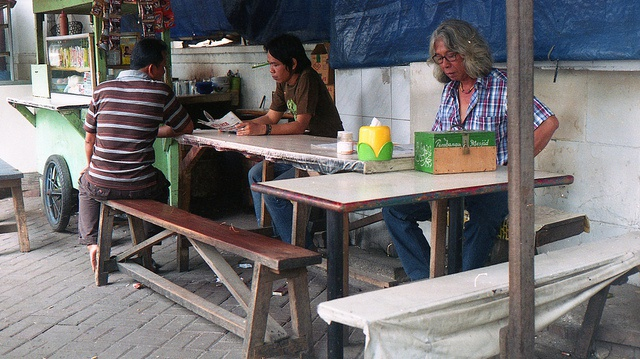Describe the objects in this image and their specific colors. I can see bench in black, gray, darkgray, and maroon tones, bench in black, lightgray, darkgray, and gray tones, people in black, gray, navy, and brown tones, people in black, gray, maroon, and darkgray tones, and dining table in black, lightgray, gray, and maroon tones in this image. 